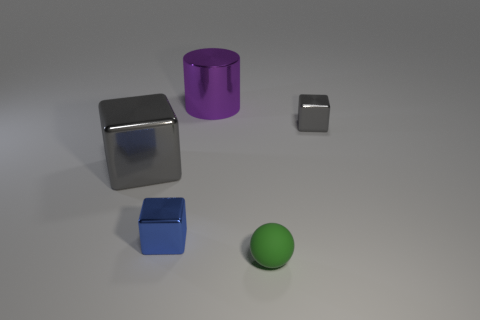There is a cube that is on the right side of the small metal thing that is left of the gray block that is on the right side of the large gray block; what is its size?
Ensure brevity in your answer.  Small. Is the shape of the tiny blue metal thing the same as the gray object to the right of the green thing?
Your response must be concise. Yes. What is the size of the blue block that is the same material as the big purple thing?
Your response must be concise. Small. There is a gray thing that is left of the cube that is to the right of the tiny shiny thing left of the rubber sphere; what is it made of?
Provide a short and direct response. Metal. Is the matte object the same color as the large shiny cylinder?
Your response must be concise. No. Are there any other things that are made of the same material as the large cube?
Make the answer very short. Yes. What number of things are either large metallic cylinders or small green objects that are in front of the small blue block?
Offer a terse response. 2. Is the size of the gray object left of the metal cylinder the same as the big metal cylinder?
Ensure brevity in your answer.  Yes. How many other things are there of the same shape as the small green rubber object?
Ensure brevity in your answer.  0. What number of blue things are either spheres or small objects?
Provide a succinct answer. 1. 